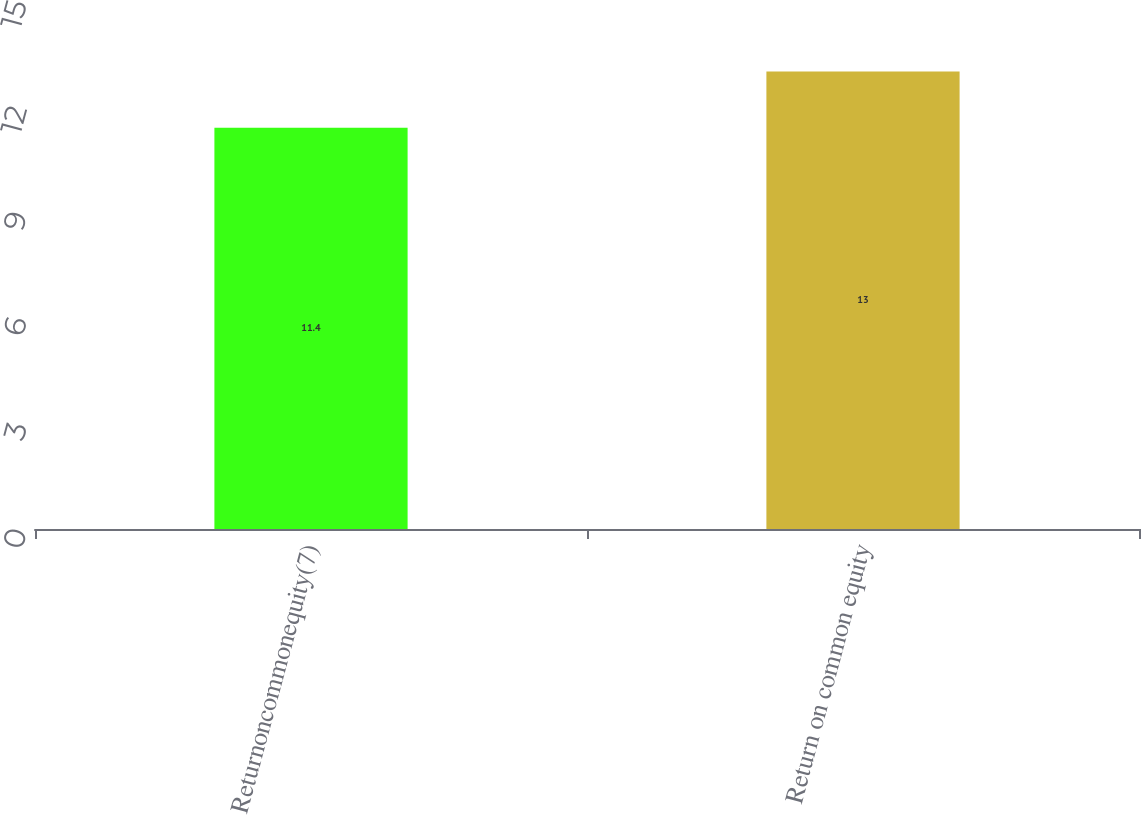Convert chart. <chart><loc_0><loc_0><loc_500><loc_500><bar_chart><fcel>Returnoncommonequity(7)<fcel>Return on common equity<nl><fcel>11.4<fcel>13<nl></chart> 